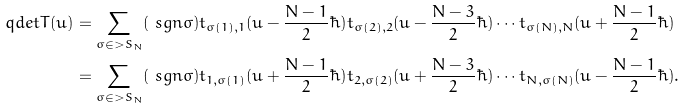Convert formula to latex. <formula><loc_0><loc_0><loc_500><loc_500>\ q d e t T ( u ) & = \sum _ { \sigma \in > S _ { N } } ( \ s g n \sigma ) t _ { \sigma ( 1 ) , 1 } ( u - \frac { N - 1 } { 2 } \hbar { ) } t _ { \sigma ( 2 ) , 2 } ( u - \frac { N - 3 } { 2 } \hbar { ) } \cdots t _ { \sigma ( N ) , N } ( u + \frac { N - 1 } { 2 } \hbar { ) } \\ & = \sum _ { \sigma \in > S _ { N } } ( \ s g n \sigma ) t _ { 1 , \sigma ( 1 ) } ( u + \frac { N - 1 } { 2 } \hbar { ) } t _ { 2 , \sigma ( 2 ) } ( u + \frac { N - 3 } { 2 } \hbar { ) } \cdots t _ { N , \sigma ( N ) } ( u - \frac { N - 1 } { 2 } \hbar { ) } .</formula> 